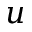Convert formula to latex. <formula><loc_0><loc_0><loc_500><loc_500>u</formula> 